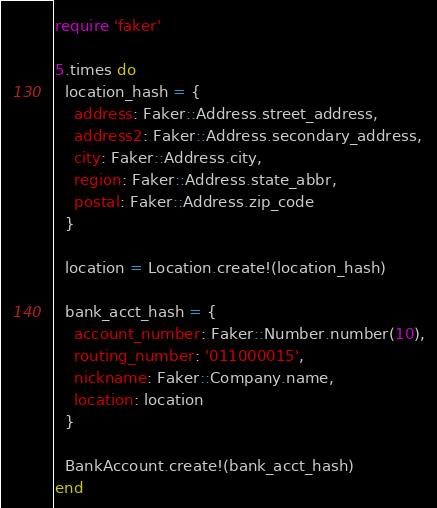Convert code to text. <code><loc_0><loc_0><loc_500><loc_500><_Ruby_>require 'faker'

5.times do
  location_hash = {
    address: Faker::Address.street_address,
    address2: Faker::Address.secondary_address,
    city: Faker::Address.city,
    region: Faker::Address.state_abbr,
    postal: Faker::Address.zip_code
  }

  location = Location.create!(location_hash)

  bank_acct_hash = {
    account_number: Faker::Number.number(10),
    routing_number: '011000015',
    nickname: Faker::Company.name,
    location: location
  }

  BankAccount.create!(bank_acct_hash)
end


</code> 